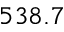Convert formula to latex. <formula><loc_0><loc_0><loc_500><loc_500>5 3 8 . 7</formula> 